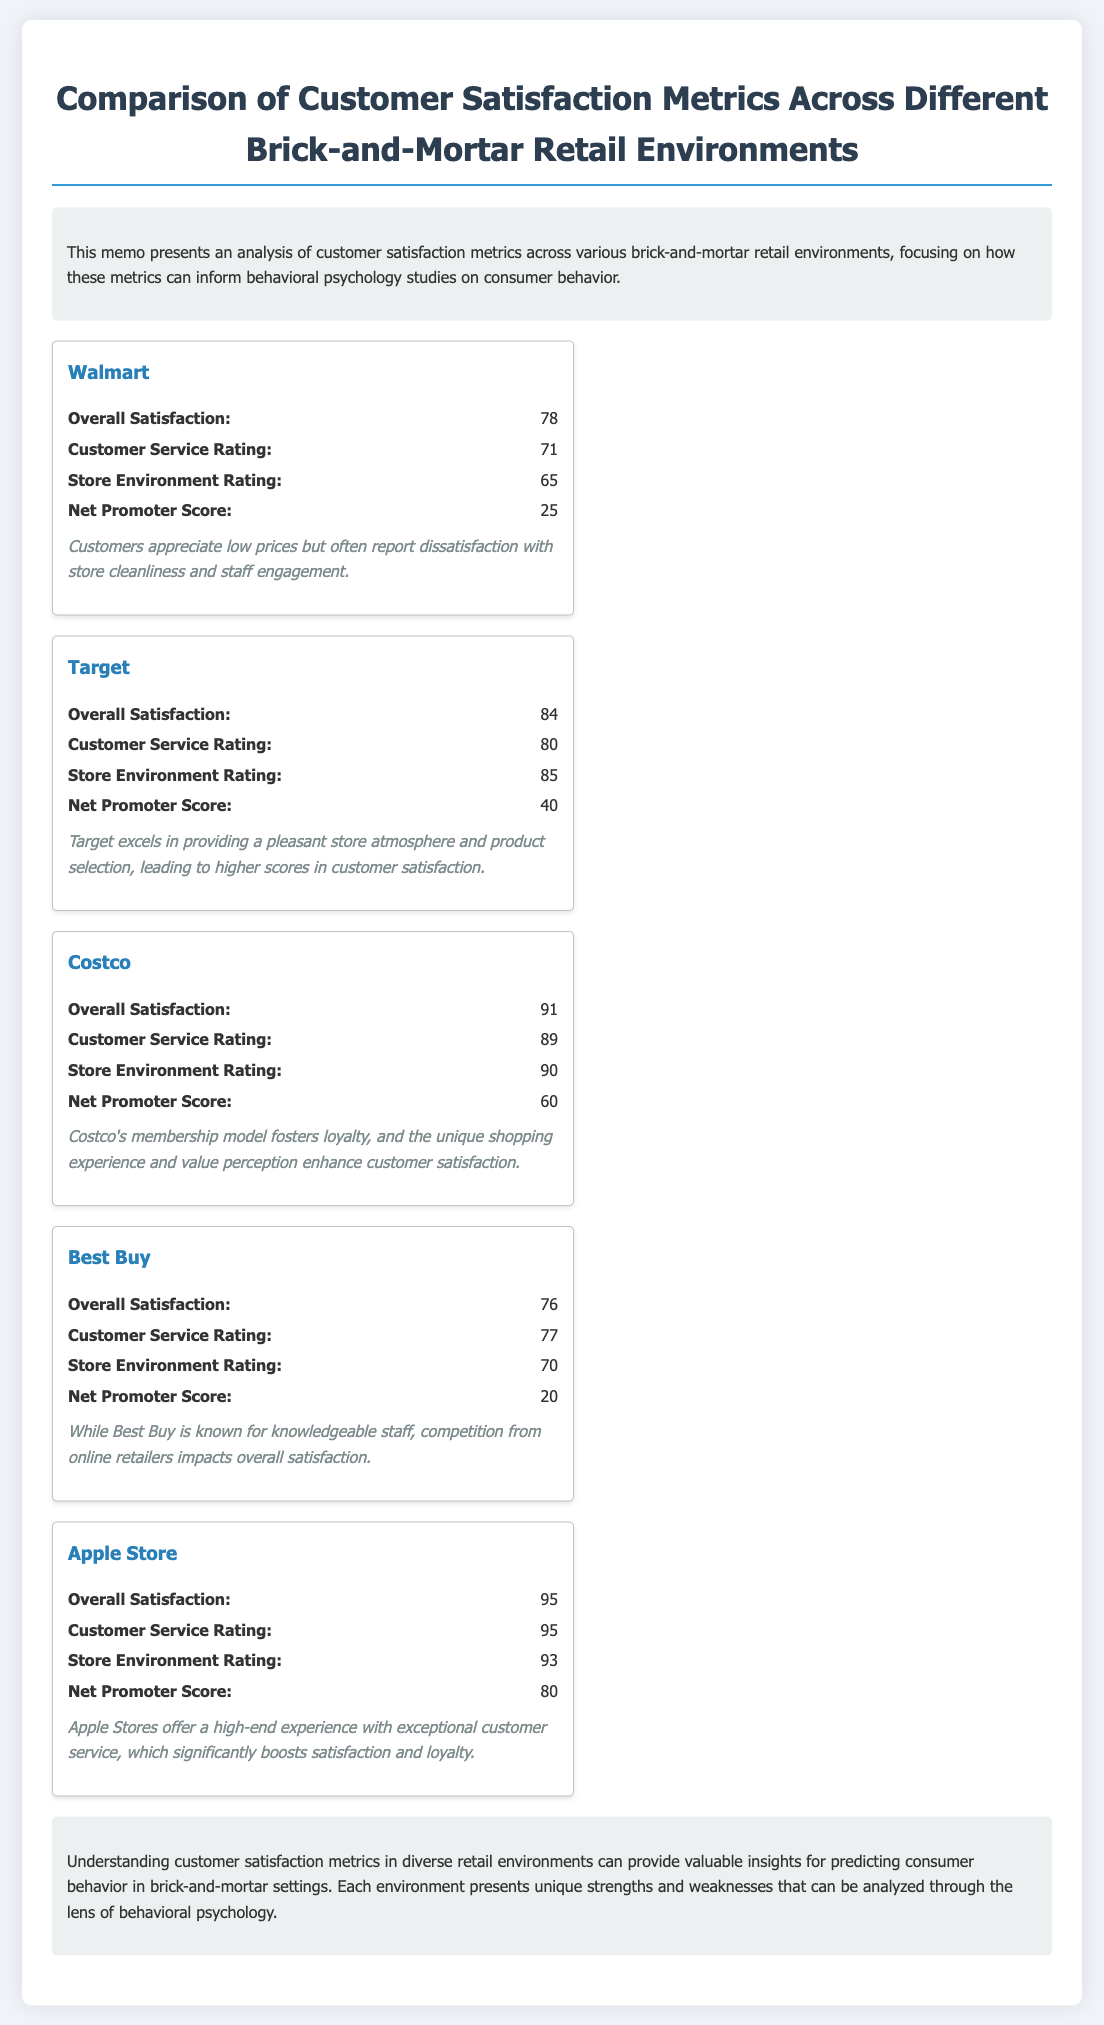What is the overall satisfaction score for Walmart? The overall satisfaction score for Walmart is stated in the document as 78.
Answer: 78 Which retail environment has the highest customer service rating? The document lists customer service ratings, and Apple Store has the highest rating of 95.
Answer: 95 What is the Net Promoter Score for Target? The document provides the Net Promoter Score for Target as 40.
Answer: 40 Which retail environment has the lowest store environment rating? The lowest store environment rating is from Walmart, which is 65.
Answer: 65 What insight is provided for Costco? The insight provided for Costco mentions that its membership model fosters loyalty and enhances customer satisfaction.
Answer: Membership model fosters loyalty What is the main conclusion of the memo? The main conclusion discusses valuable insights in predicting consumer behavior through customer satisfaction metrics across various retail environments.
Answer: Valuable insights for predicting consumer behavior How many retail environments are compared in the document? The document lists a total of five retail environments compared.
Answer: Five What is the overall satisfaction score of the Apple Store? The overall satisfaction score for the Apple Store is indicated as 95.
Answer: 95 What does the insight for Best Buy mention? The insight for Best Buy highlights that competition from online retailers impacts overall satisfaction.
Answer: Competition from online retailers impacts satisfaction 